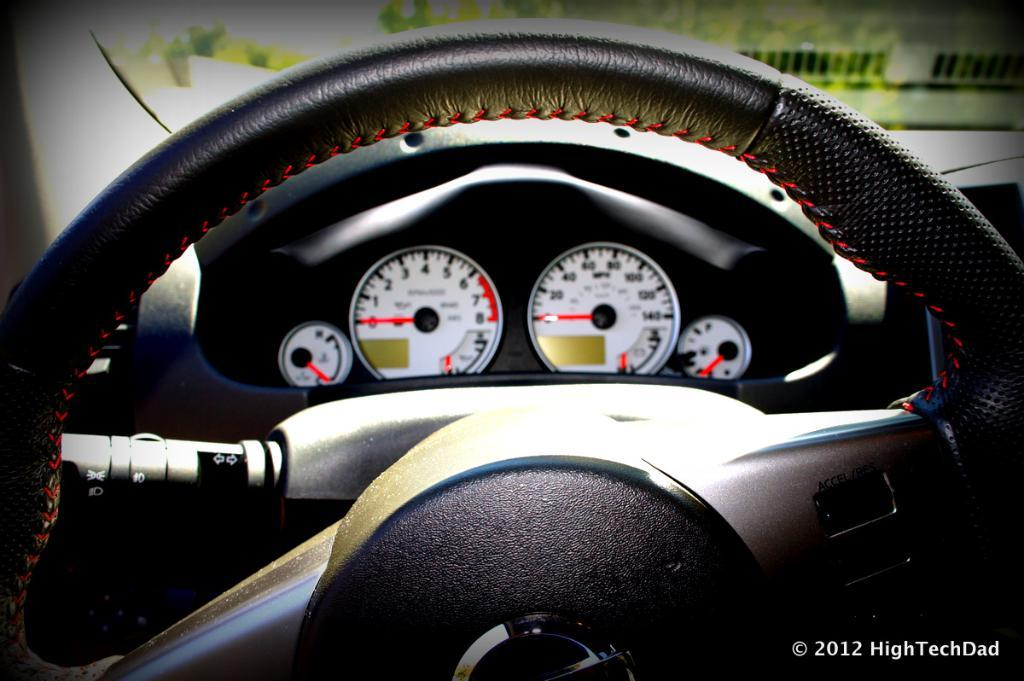What is the main object in the image? There is a steering wheel in the image. What is the color of the steering wheel? The steering wheel is black in color. What other instrument is present in the image? There is a speedometer and a fuel meter in the image. What can be seen through the windshield in the image? The presence of a windshield suggests that there might be a view of the road or surroundings, but this information is not explicitly provided in the facts. What type of flowers can be seen growing near the steering wheel in the image? There are no flowers present in the image; it features a steering wheel, speedometer, fuel meter, and windshield. Is there any indication of winter weather in the image? The provided facts do not mention any weather conditions, so it cannot be determined if it is winter or not. 